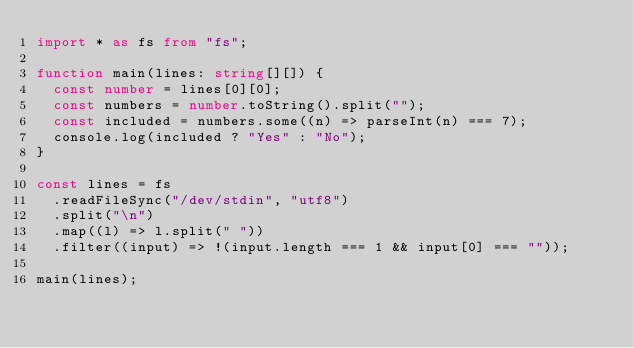Convert code to text. <code><loc_0><loc_0><loc_500><loc_500><_TypeScript_>import * as fs from "fs";

function main(lines: string[][]) {
  const number = lines[0][0];
  const numbers = number.toString().split("");
  const included = numbers.some((n) => parseInt(n) === 7);
  console.log(included ? "Yes" : "No");
}

const lines = fs
  .readFileSync("/dev/stdin", "utf8")
  .split("\n")
  .map((l) => l.split(" "))
  .filter((input) => !(input.length === 1 && input[0] === ""));

main(lines);
</code> 